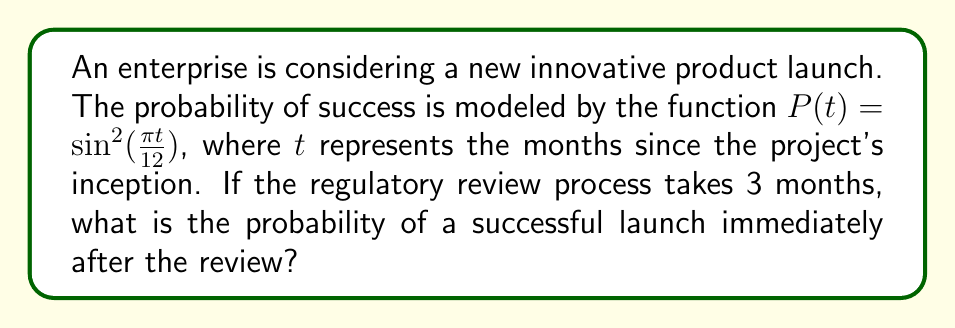Could you help me with this problem? Let's approach this step-by-step:

1) We are given the probability function:
   $P(t) = \sin^2(\frac{\pi t}{12})$

2) The regulatory review process takes 3 months, so we need to evaluate P(t) at t = 3:
   $P(3) = \sin^2(\frac{\pi \cdot 3}{12})$

3) Let's simplify the argument of the sine function:
   $\frac{\pi \cdot 3}{12} = \frac{\pi}{4}$

4) Now our equation looks like this:
   $P(3) = \sin^2(\frac{\pi}{4})$

5) Recall that $\sin(\frac{\pi}{4}) = \frac{\sqrt{2}}{2}$

6) Therefore:
   $P(3) = (\frac{\sqrt{2}}{2})^2 = \frac{2}{4} = \frac{1}{2}$

7) Convert to a percentage:
   $\frac{1}{2} = 50\%$

Thus, the probability of a successful launch immediately after the 3-month review is 50%.
Answer: 50% 